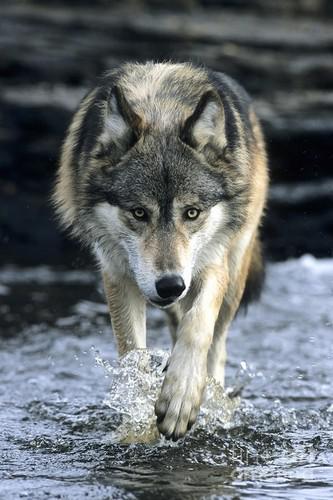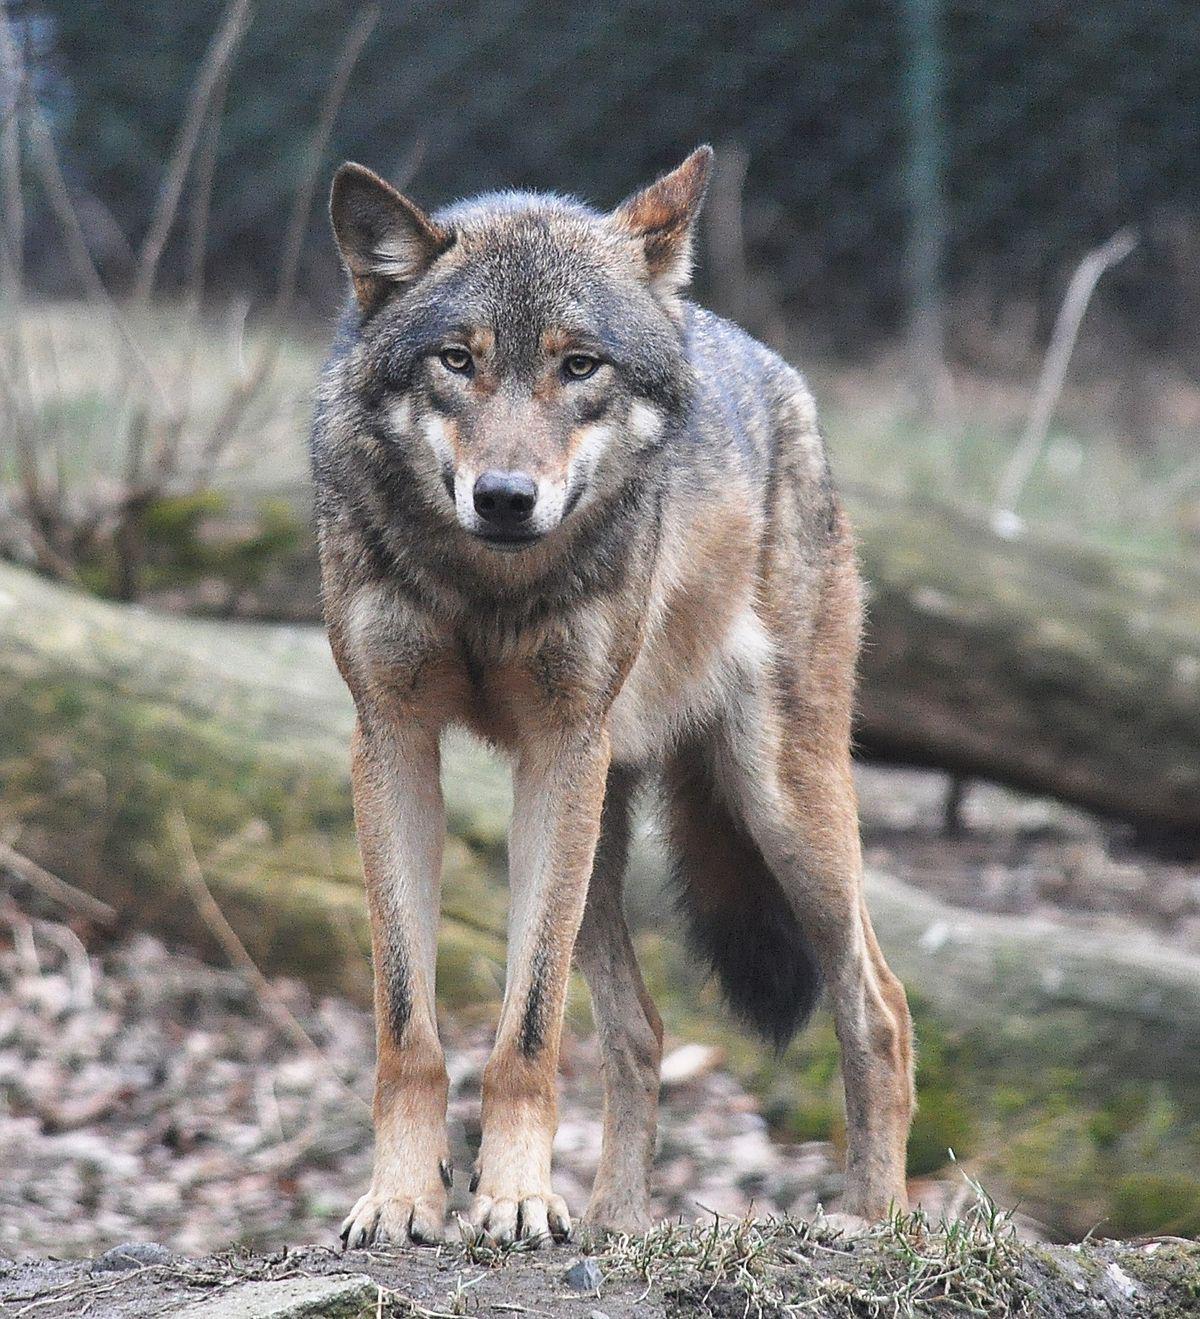The first image is the image on the left, the second image is the image on the right. Given the left and right images, does the statement "The animal in the image on the right has an open mouth." hold true? Answer yes or no. No. 